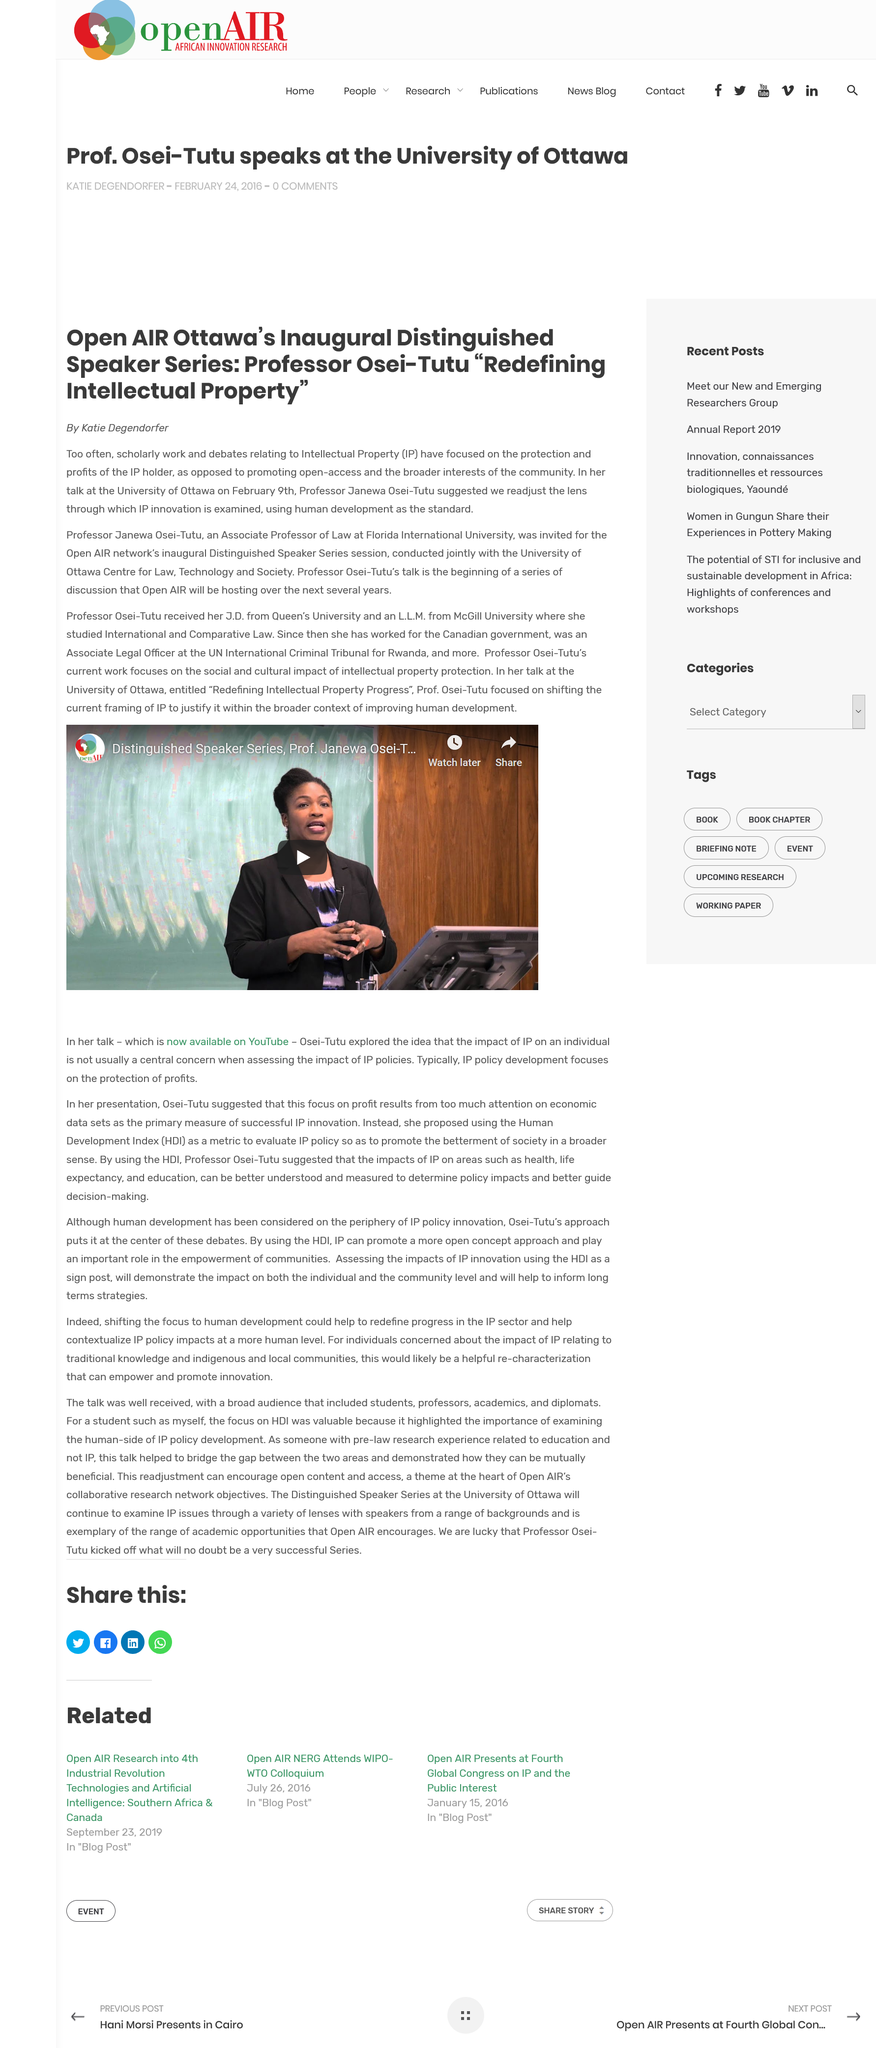Give some essential details in this illustration. IP stands for Intellectual Property. The professor is coming from the Florida International University. She hails from the esteemed institution of higher learning. Professor Osei-Tutu was speaking. 